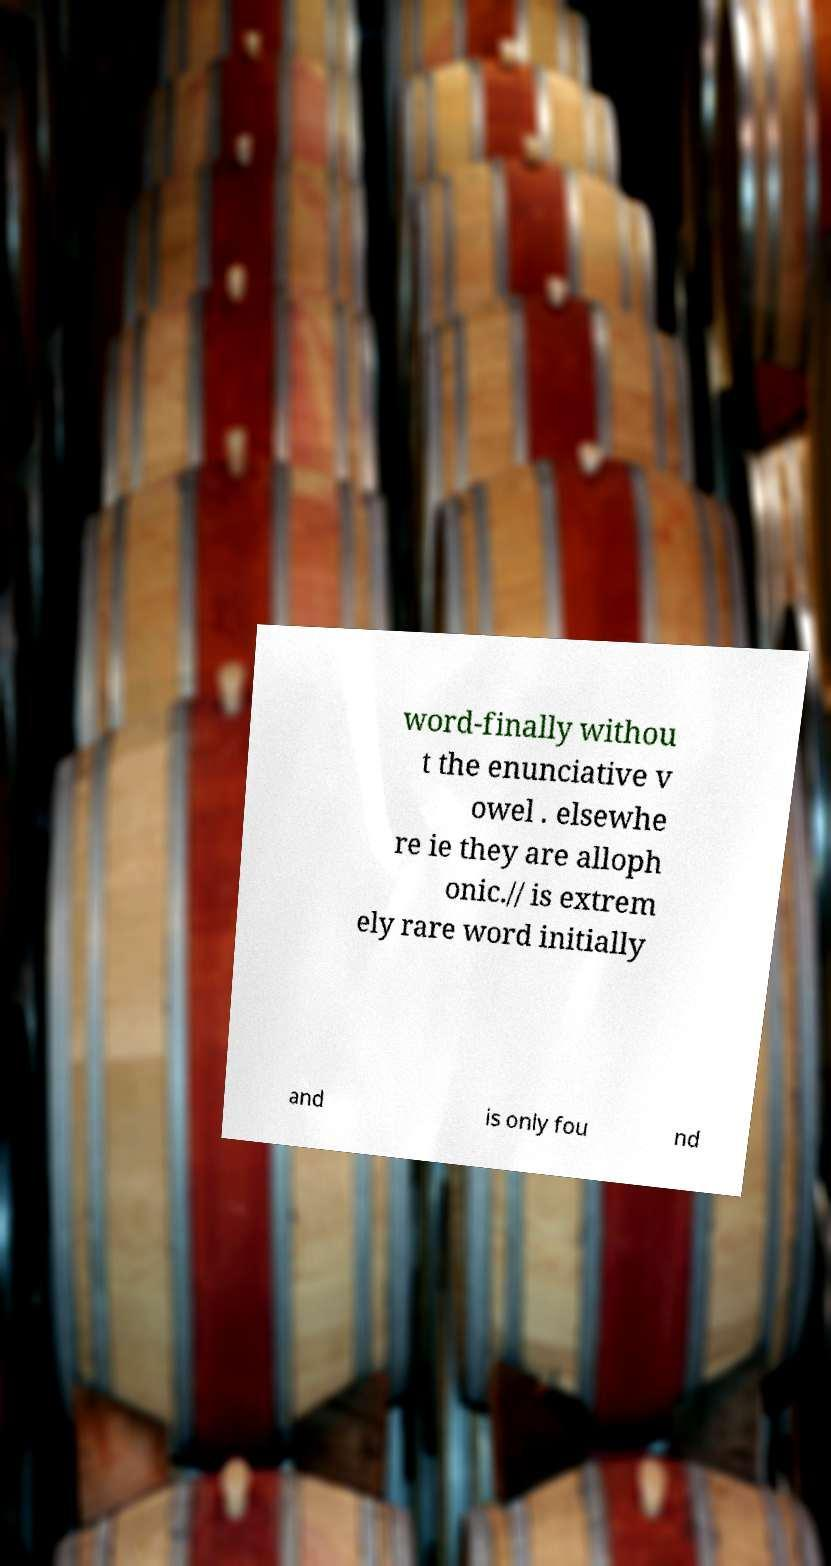Can you accurately transcribe the text from the provided image for me? word-finally withou t the enunciative v owel . elsewhe re ie they are alloph onic.// is extrem ely rare word initially and is only fou nd 